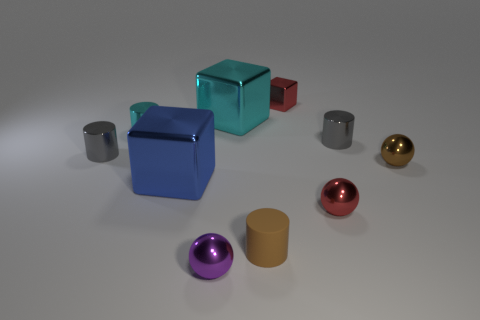Subtract all cyan blocks. How many red balls are left? 1 Subtract all matte things. Subtract all small brown things. How many objects are left? 7 Add 5 cyan cylinders. How many cyan cylinders are left? 6 Add 2 small brown things. How many small brown things exist? 4 Subtract all purple balls. How many balls are left? 2 Subtract all red metal spheres. How many spheres are left? 2 Subtract 0 brown blocks. How many objects are left? 10 Subtract all cylinders. How many objects are left? 6 Subtract 3 balls. How many balls are left? 0 Subtract all purple balls. Subtract all gray cubes. How many balls are left? 2 